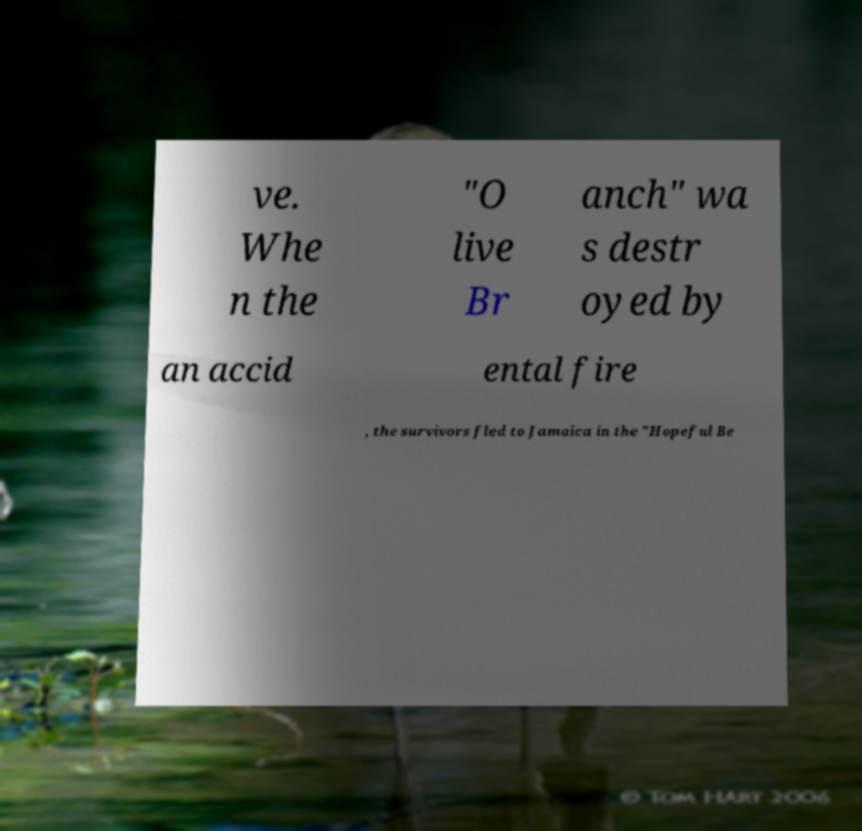There's text embedded in this image that I need extracted. Can you transcribe it verbatim? ve. Whe n the "O live Br anch" wa s destr oyed by an accid ental fire , the survivors fled to Jamaica in the "Hopeful Be 